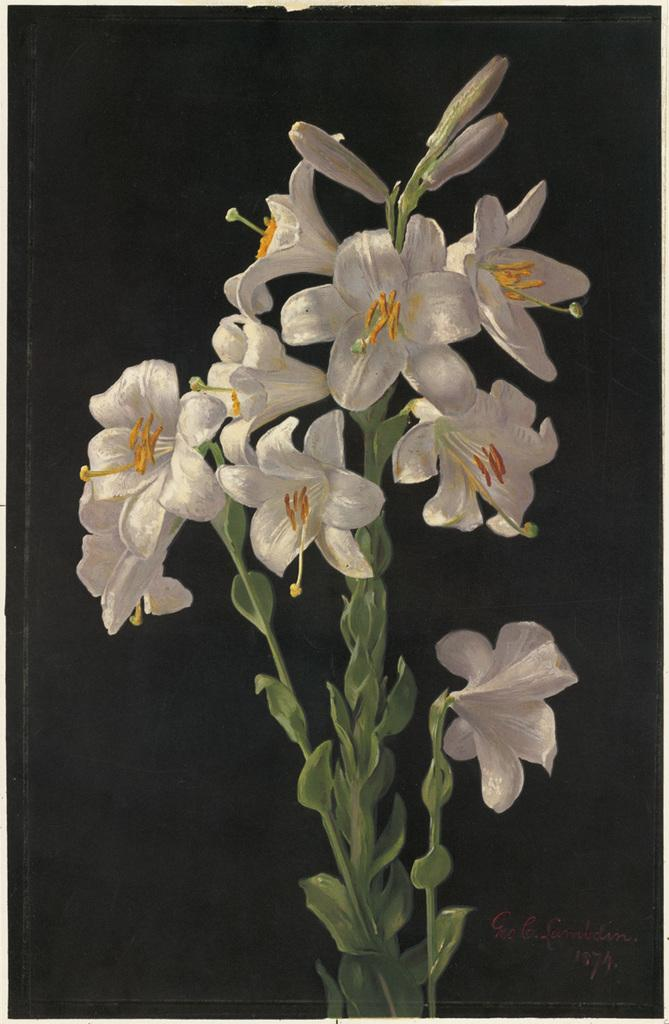What colors are the flowers in the image? The flowers in the image are white and yellow. Where are the flowers located? The flowers are on a plant. What color is the background of the image? The background of the image is black. What type of car can be seen crushing the flowers in the image? There is no car present in the image, and the flowers are not being crushed. 